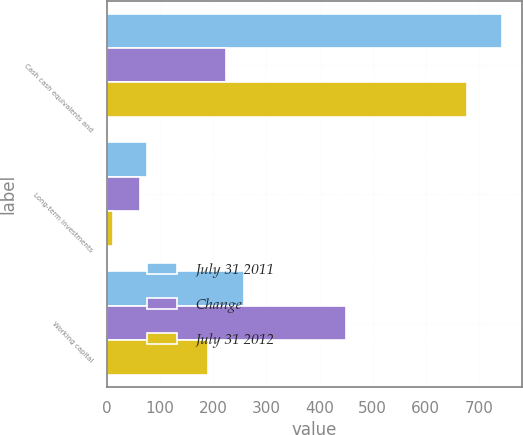Convert chart. <chart><loc_0><loc_0><loc_500><loc_500><stacked_bar_chart><ecel><fcel>Cash cash equivalents and<fcel>Long-term investments<fcel>Working capital<nl><fcel>July 31 2011<fcel>744<fcel>75<fcel>258<nl><fcel>Change<fcel>224.5<fcel>63<fcel>449<nl><fcel>July 31 2012<fcel>677<fcel>12<fcel>191<nl></chart> 